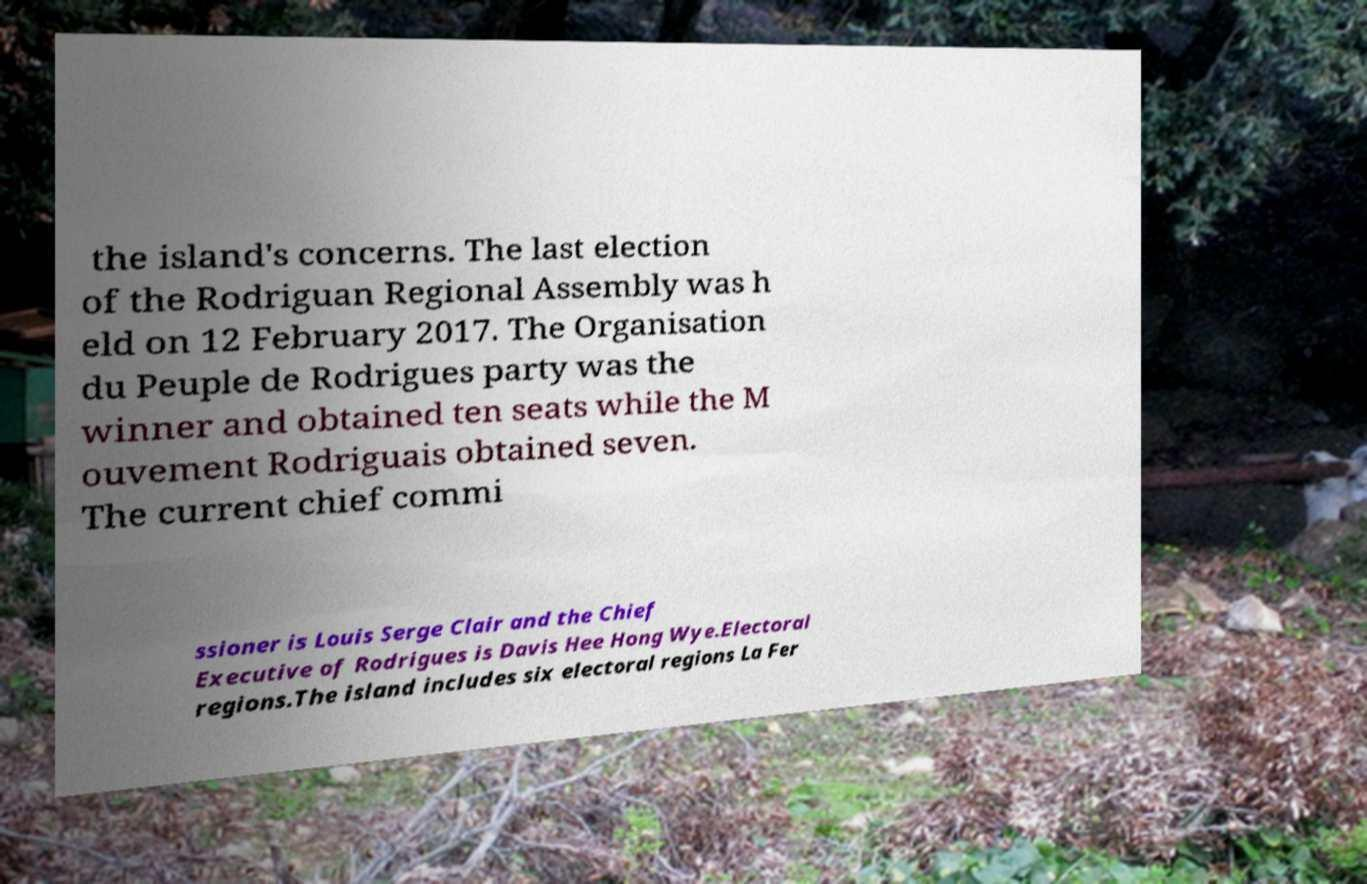What messages or text are displayed in this image? I need them in a readable, typed format. the island's concerns. The last election of the Rodriguan Regional Assembly was h eld on 12 February 2017. The Organisation du Peuple de Rodrigues party was the winner and obtained ten seats while the M ouvement Rodriguais obtained seven. The current chief commi ssioner is Louis Serge Clair and the Chief Executive of Rodrigues is Davis Hee Hong Wye.Electoral regions.The island includes six electoral regions La Fer 